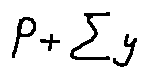Convert formula to latex. <formula><loc_0><loc_0><loc_500><loc_500>P + \sum y</formula> 